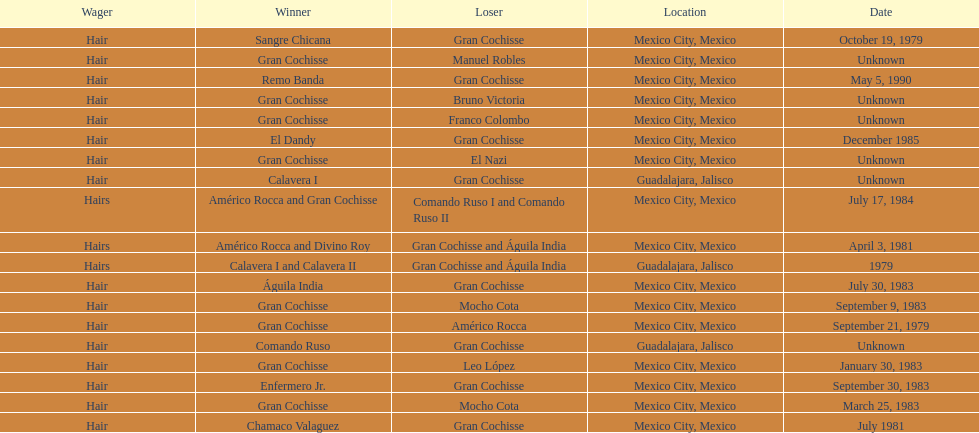How many winners were there before bruno victoria lost? 3. 